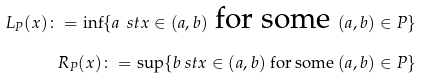Convert formula to latex. <formula><loc_0><loc_0><loc_500><loc_500>L _ { P } ( x ) \colon = \inf \{ a \ s t x \in ( a , b ) \text { for some } ( a , b ) \in P \} \\ R _ { P } ( x ) \colon = \sup \{ b \ s t x \in ( a , b ) \text { for some } ( a , b ) \in P \}</formula> 